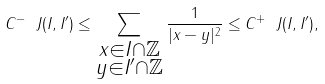<formula> <loc_0><loc_0><loc_500><loc_500>C ^ { - } \ J ( I , I ^ { \prime } ) \leq \sum _ { \substack { x \in I \cap \mathbb { Z } \\ y \in I ^ { \prime } \cap \mathbb { Z } } } \frac { 1 } { | x - y | ^ { 2 } } \leq C ^ { + } \ J ( I , I ^ { \prime } ) ,</formula> 